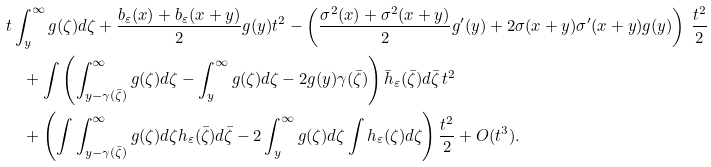<formula> <loc_0><loc_0><loc_500><loc_500>& { t \int _ { y } ^ { \infty } g ( \zeta ) d \zeta + \frac { { b _ { \varepsilon } ( x ) + b _ { \varepsilon } ( x + y ) } } { 2 } g ( y ) t ^ { 2 } - \left ( \frac { \sigma ^ { 2 } ( x ) + \sigma ^ { 2 } ( x + y ) } { 2 } g ^ { \prime } ( y ) + 2 \sigma ( x + y ) \sigma ^ { \prime } ( x + y ) g ( y ) \right ) \, \frac { t ^ { 2 } } { 2 } } \\ & \quad + { \int \left ( \int _ { y - \gamma ( \bar { \zeta } ) } ^ { \infty } g ( \zeta ) d \zeta - \int _ { y } ^ { \infty } g ( \zeta ) d \zeta - { 2 g ( y ) \gamma ( \bar { \zeta } ) } \right ) \bar { h } _ { \varepsilon } ( { \bar { \zeta } } ) d { \bar { \zeta } } \, t ^ { 2 } } \\ & \quad + { \left ( \int \int _ { y - \gamma ( { \bar { \zeta } } ) } ^ { \infty } g ( \zeta ) d \zeta h _ { \varepsilon } ( { \bar { \zeta } } ) d { \bar { \zeta } } - 2 \int _ { y } ^ { \infty } g ( \zeta ) d \zeta \int h _ { \varepsilon } ( \zeta ) d \zeta \right ) \frac { t ^ { 2 } } { 2 } + O ( t ^ { 3 } ) } .</formula> 